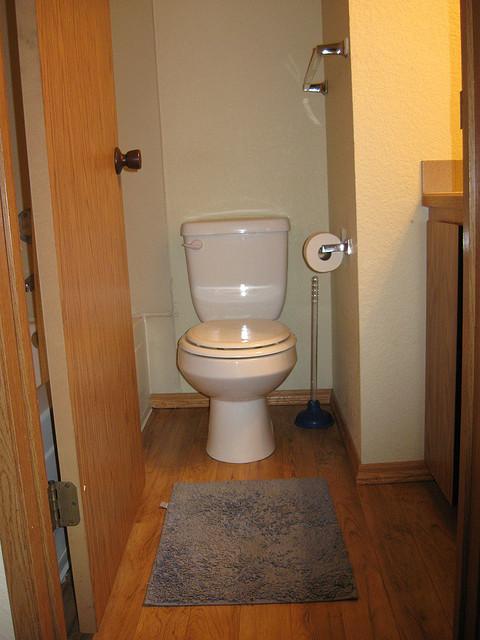Can someone get a device to unclog the toilet?
Quick response, please. Yes. Is this a large bathroom?
Short answer required. No. What color is the plunger?
Concise answer only. Black. How many towels are in the bathroom?
Give a very brief answer. 0. What color is the bath mat?
Keep it brief. Gray. 